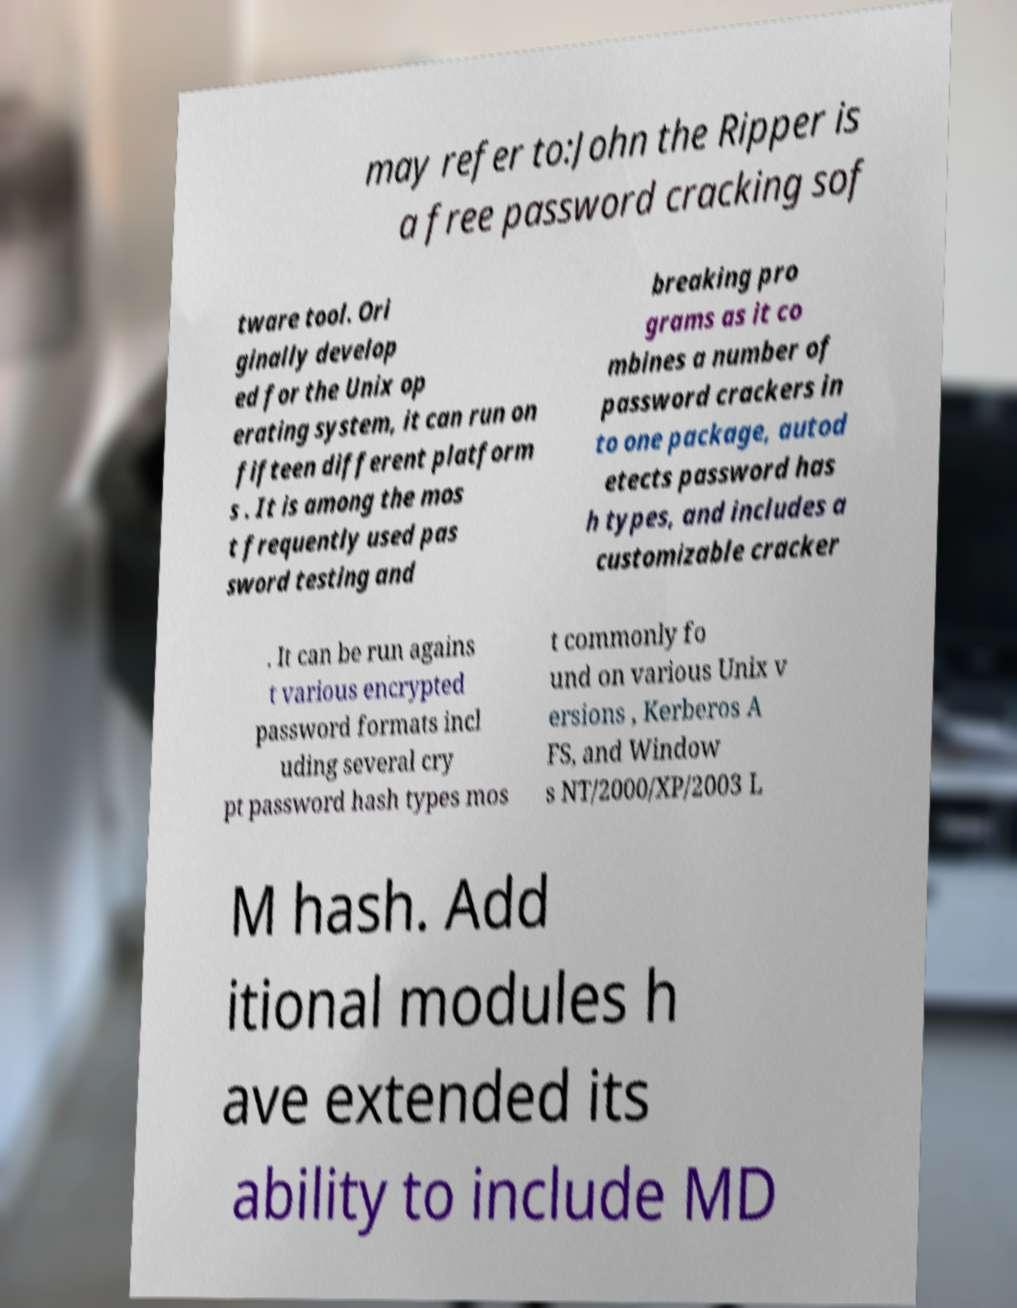I need the written content from this picture converted into text. Can you do that? may refer to:John the Ripper is a free password cracking sof tware tool. Ori ginally develop ed for the Unix op erating system, it can run on fifteen different platform s . It is among the mos t frequently used pas sword testing and breaking pro grams as it co mbines a number of password crackers in to one package, autod etects password has h types, and includes a customizable cracker . It can be run agains t various encrypted password formats incl uding several cry pt password hash types mos t commonly fo und on various Unix v ersions , Kerberos A FS, and Window s NT/2000/XP/2003 L M hash. Add itional modules h ave extended its ability to include MD 